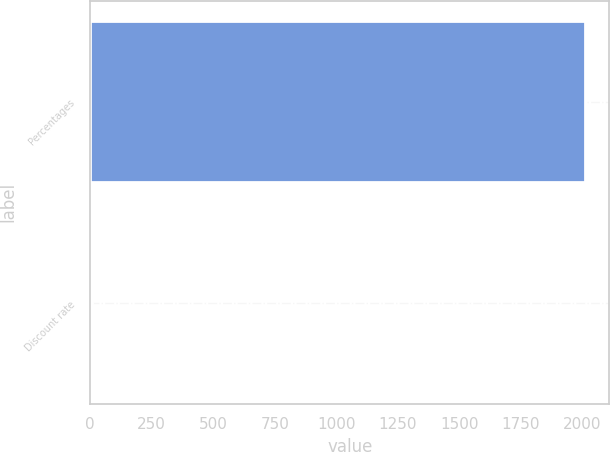Convert chart. <chart><loc_0><loc_0><loc_500><loc_500><bar_chart><fcel>Percentages<fcel>Discount rate<nl><fcel>2009<fcel>6.25<nl></chart> 